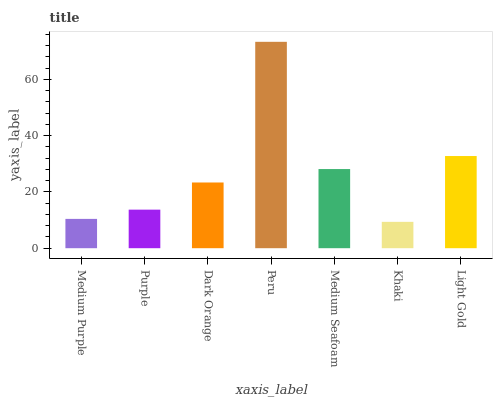Is Khaki the minimum?
Answer yes or no. Yes. Is Peru the maximum?
Answer yes or no. Yes. Is Purple the minimum?
Answer yes or no. No. Is Purple the maximum?
Answer yes or no. No. Is Purple greater than Medium Purple?
Answer yes or no. Yes. Is Medium Purple less than Purple?
Answer yes or no. Yes. Is Medium Purple greater than Purple?
Answer yes or no. No. Is Purple less than Medium Purple?
Answer yes or no. No. Is Dark Orange the high median?
Answer yes or no. Yes. Is Dark Orange the low median?
Answer yes or no. Yes. Is Medium Seafoam the high median?
Answer yes or no. No. Is Purple the low median?
Answer yes or no. No. 